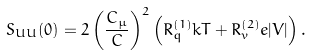Convert formula to latex. <formula><loc_0><loc_0><loc_500><loc_500>S _ { U U } ( 0 ) = 2 \left ( \frac { C _ { \mu } } { C } \right ) ^ { 2 } \left ( R ^ { ( 1 ) } _ { q } k T + R ^ { ( 2 ) } _ { v } e | V | \right ) .</formula> 